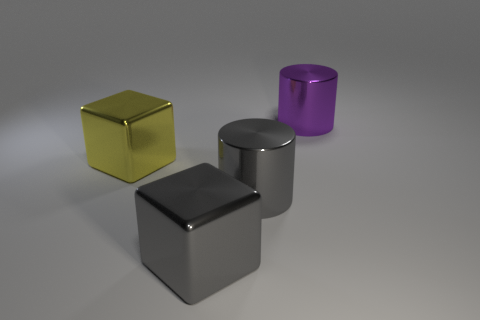There is a metallic thing that is to the left of the large purple shiny thing and behind the large gray cylinder; how big is it?
Make the answer very short. Large. Are there fewer large gray metal cylinders than large brown shiny blocks?
Give a very brief answer. No. There is a shiny cylinder that is left of the purple metallic object; what is its size?
Make the answer very short. Large. The big metallic thing that is behind the gray cube and in front of the yellow block has what shape?
Ensure brevity in your answer.  Cylinder. There is another thing that is the same shape as the purple metal object; what is its size?
Keep it short and to the point. Large. How many other large gray cubes have the same material as the gray cube?
Make the answer very short. 0. Are there more small blue objects than objects?
Your answer should be very brief. No. There is a yellow thing in front of the large purple shiny cylinder; is it the same shape as the big purple metal thing?
Make the answer very short. No. Is the number of yellow objects on the right side of the purple shiny object less than the number of cubes that are on the left side of the yellow metal cube?
Make the answer very short. No. What is the cylinder that is on the left side of the large purple cylinder made of?
Keep it short and to the point. Metal. 